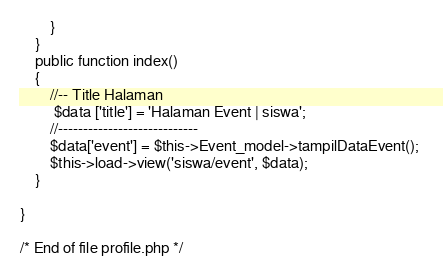Convert code to text. <code><loc_0><loc_0><loc_500><loc_500><_PHP_>        }
    }
    public function index()
    {
        //-- Title Halaman
         $data ['title'] = 'Halaman Event | siswa';
        //----------------------------
        $data['event'] = $this->Event_model->tampilDataEvent(); 
        $this->load->view('siswa/event', $data);
    } 

}

/* End of file profile.php */
</code> 